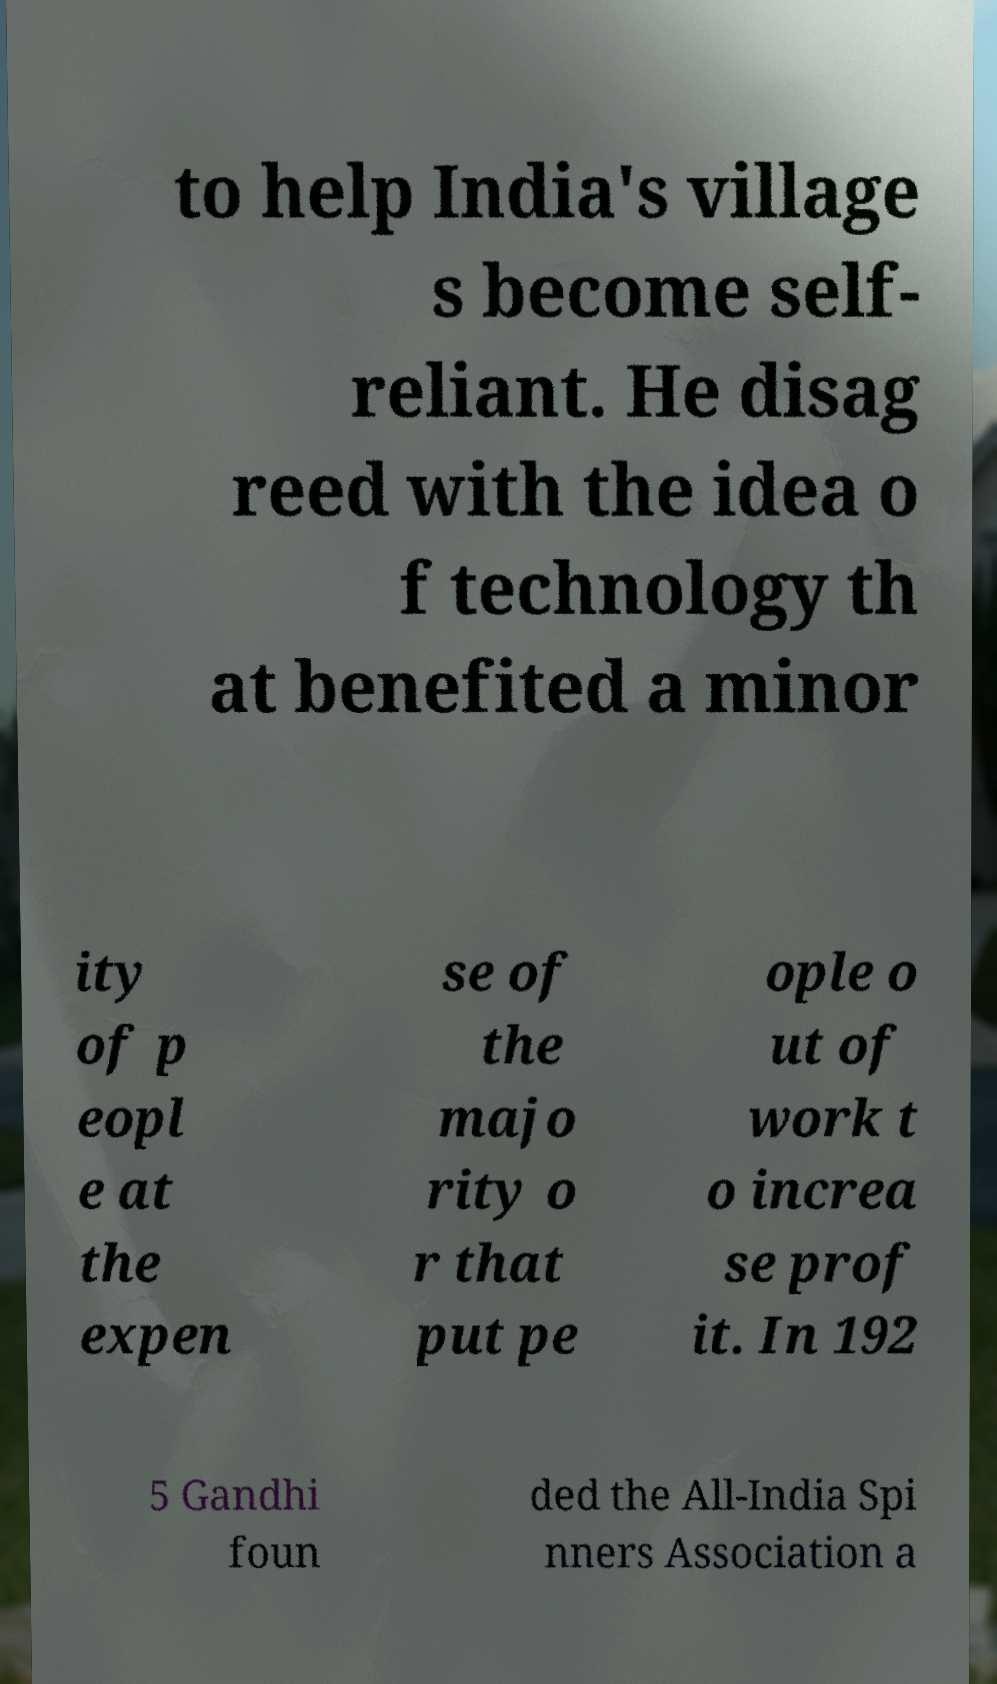There's text embedded in this image that I need extracted. Can you transcribe it verbatim? to help India's village s become self- reliant. He disag reed with the idea o f technology th at benefited a minor ity of p eopl e at the expen se of the majo rity o r that put pe ople o ut of work t o increa se prof it. In 192 5 Gandhi foun ded the All-India Spi nners Association a 